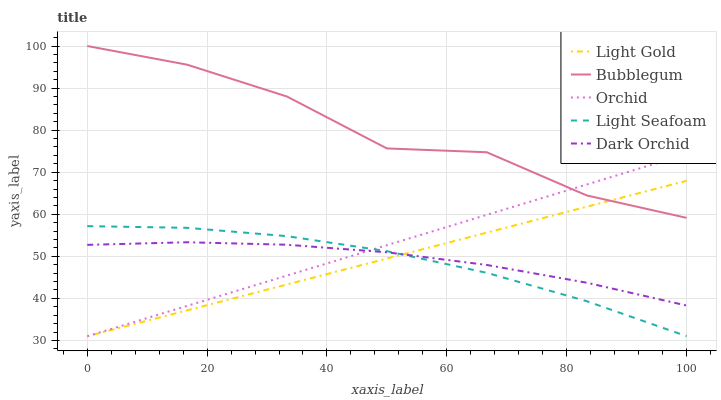Does Light Gold have the minimum area under the curve?
Answer yes or no. No. Does Light Gold have the maximum area under the curve?
Answer yes or no. No. Is Light Gold the smoothest?
Answer yes or no. No. Is Light Gold the roughest?
Answer yes or no. No. Does Dark Orchid have the lowest value?
Answer yes or no. No. Does Light Gold have the highest value?
Answer yes or no. No. Is Light Seafoam less than Bubblegum?
Answer yes or no. Yes. Is Bubblegum greater than Light Seafoam?
Answer yes or no. Yes. Does Light Seafoam intersect Bubblegum?
Answer yes or no. No. 